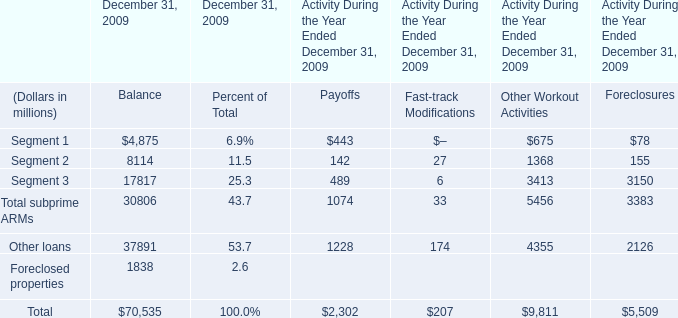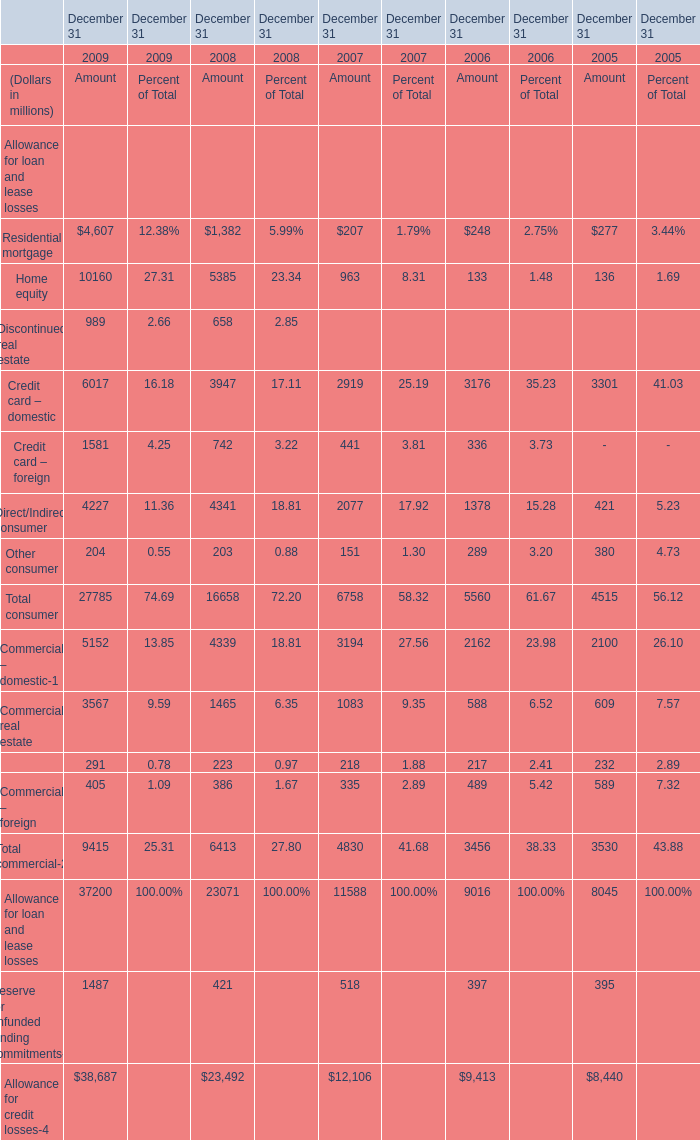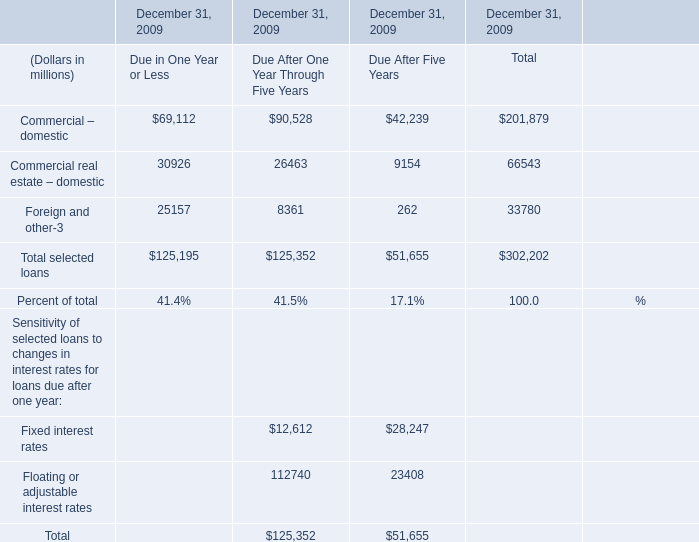What's the increasing rate of Credit card – domestic in 2009? 
Computations: ((6017 - 3947) / 3947)
Answer: 0.52445. 